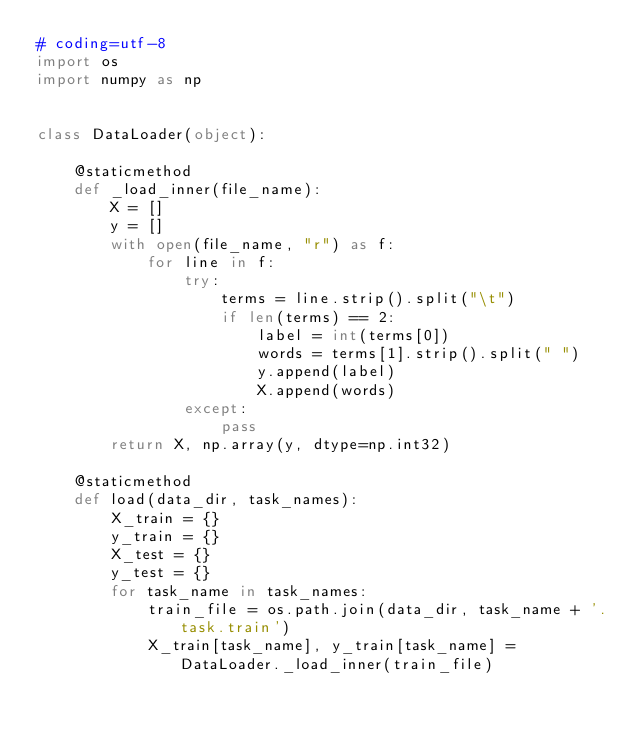<code> <loc_0><loc_0><loc_500><loc_500><_Python_># coding=utf-8
import os
import numpy as np


class DataLoader(object):

    @staticmethod
    def _load_inner(file_name):
        X = []
        y = []
        with open(file_name, "r") as f:
            for line in f:
                try:
                    terms = line.strip().split("\t")
                    if len(terms) == 2:
                        label = int(terms[0])
                        words = terms[1].strip().split(" ")
                        y.append(label)
                        X.append(words)
                except:
                    pass
        return X, np.array(y, dtype=np.int32)

    @staticmethod
    def load(data_dir, task_names):
        X_train = {}
        y_train = {}
        X_test = {}
        y_test = {}
        for task_name in task_names:
            train_file = os.path.join(data_dir, task_name + '.task.train')
            X_train[task_name], y_train[task_name] = DataLoader._load_inner(train_file)</code> 